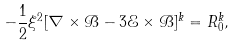<formula> <loc_0><loc_0><loc_500><loc_500>- \frac { 1 } { 2 } \xi ^ { 2 } [ \nabla \times { \mathcal { B } } - 3 \mathcal { E } \times { \mathcal { B } } ] ^ { k } = R ^ { k } _ { 0 } ,</formula> 